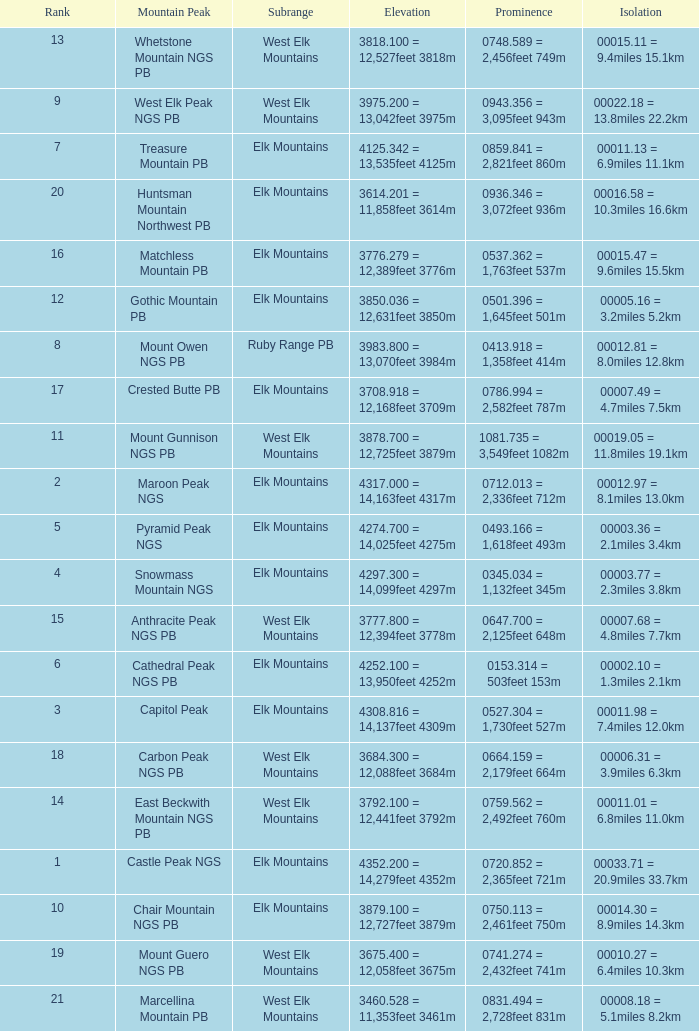Parse the table in full. {'header': ['Rank', 'Mountain Peak', 'Subrange', 'Elevation', 'Prominence', 'Isolation'], 'rows': [['13', 'Whetstone Mountain NGS PB', 'West Elk Mountains', '3818.100 = 12,527feet 3818m', '0748.589 = 2,456feet 749m', '00015.11 = 9.4miles 15.1km'], ['9', 'West Elk Peak NGS PB', 'West Elk Mountains', '3975.200 = 13,042feet 3975m', '0943.356 = 3,095feet 943m', '00022.18 = 13.8miles 22.2km'], ['7', 'Treasure Mountain PB', 'Elk Mountains', '4125.342 = 13,535feet 4125m', '0859.841 = 2,821feet 860m', '00011.13 = 6.9miles 11.1km'], ['20', 'Huntsman Mountain Northwest PB', 'Elk Mountains', '3614.201 = 11,858feet 3614m', '0936.346 = 3,072feet 936m', '00016.58 = 10.3miles 16.6km'], ['16', 'Matchless Mountain PB', 'Elk Mountains', '3776.279 = 12,389feet 3776m', '0537.362 = 1,763feet 537m', '00015.47 = 9.6miles 15.5km'], ['12', 'Gothic Mountain PB', 'Elk Mountains', '3850.036 = 12,631feet 3850m', '0501.396 = 1,645feet 501m', '00005.16 = 3.2miles 5.2km'], ['8', 'Mount Owen NGS PB', 'Ruby Range PB', '3983.800 = 13,070feet 3984m', '0413.918 = 1,358feet 414m', '00012.81 = 8.0miles 12.8km'], ['17', 'Crested Butte PB', 'Elk Mountains', '3708.918 = 12,168feet 3709m', '0786.994 = 2,582feet 787m', '00007.49 = 4.7miles 7.5km'], ['11', 'Mount Gunnison NGS PB', 'West Elk Mountains', '3878.700 = 12,725feet 3879m', '1081.735 = 3,549feet 1082m', '00019.05 = 11.8miles 19.1km'], ['2', 'Maroon Peak NGS', 'Elk Mountains', '4317.000 = 14,163feet 4317m', '0712.013 = 2,336feet 712m', '00012.97 = 8.1miles 13.0km'], ['5', 'Pyramid Peak NGS', 'Elk Mountains', '4274.700 = 14,025feet 4275m', '0493.166 = 1,618feet 493m', '00003.36 = 2.1miles 3.4km'], ['4', 'Snowmass Mountain NGS', 'Elk Mountains', '4297.300 = 14,099feet 4297m', '0345.034 = 1,132feet 345m', '00003.77 = 2.3miles 3.8km'], ['15', 'Anthracite Peak NGS PB', 'West Elk Mountains', '3777.800 = 12,394feet 3778m', '0647.700 = 2,125feet 648m', '00007.68 = 4.8miles 7.7km'], ['6', 'Cathedral Peak NGS PB', 'Elk Mountains', '4252.100 = 13,950feet 4252m', '0153.314 = 503feet 153m', '00002.10 = 1.3miles 2.1km'], ['3', 'Capitol Peak', 'Elk Mountains', '4308.816 = 14,137feet 4309m', '0527.304 = 1,730feet 527m', '00011.98 = 7.4miles 12.0km'], ['18', 'Carbon Peak NGS PB', 'West Elk Mountains', '3684.300 = 12,088feet 3684m', '0664.159 = 2,179feet 664m', '00006.31 = 3.9miles 6.3km'], ['14', 'East Beckwith Mountain NGS PB', 'West Elk Mountains', '3792.100 = 12,441feet 3792m', '0759.562 = 2,492feet 760m', '00011.01 = 6.8miles 11.0km'], ['1', 'Castle Peak NGS', 'Elk Mountains', '4352.200 = 14,279feet 4352m', '0720.852 = 2,365feet 721m', '00033.71 = 20.9miles 33.7km'], ['10', 'Chair Mountain NGS PB', 'Elk Mountains', '3879.100 = 12,727feet 3879m', '0750.113 = 2,461feet 750m', '00014.30 = 8.9miles 14.3km'], ['19', 'Mount Guero NGS PB', 'West Elk Mountains', '3675.400 = 12,058feet 3675m', '0741.274 = 2,432feet 741m', '00010.27 = 6.4miles 10.3km'], ['21', 'Marcellina Mountain PB', 'West Elk Mountains', '3460.528 = 11,353feet 3461m', '0831.494 = 2,728feet 831m', '00008.18 = 5.1miles 8.2km']]} Name the Rank of Rank Mountain Peak of crested butte pb? 17.0. 